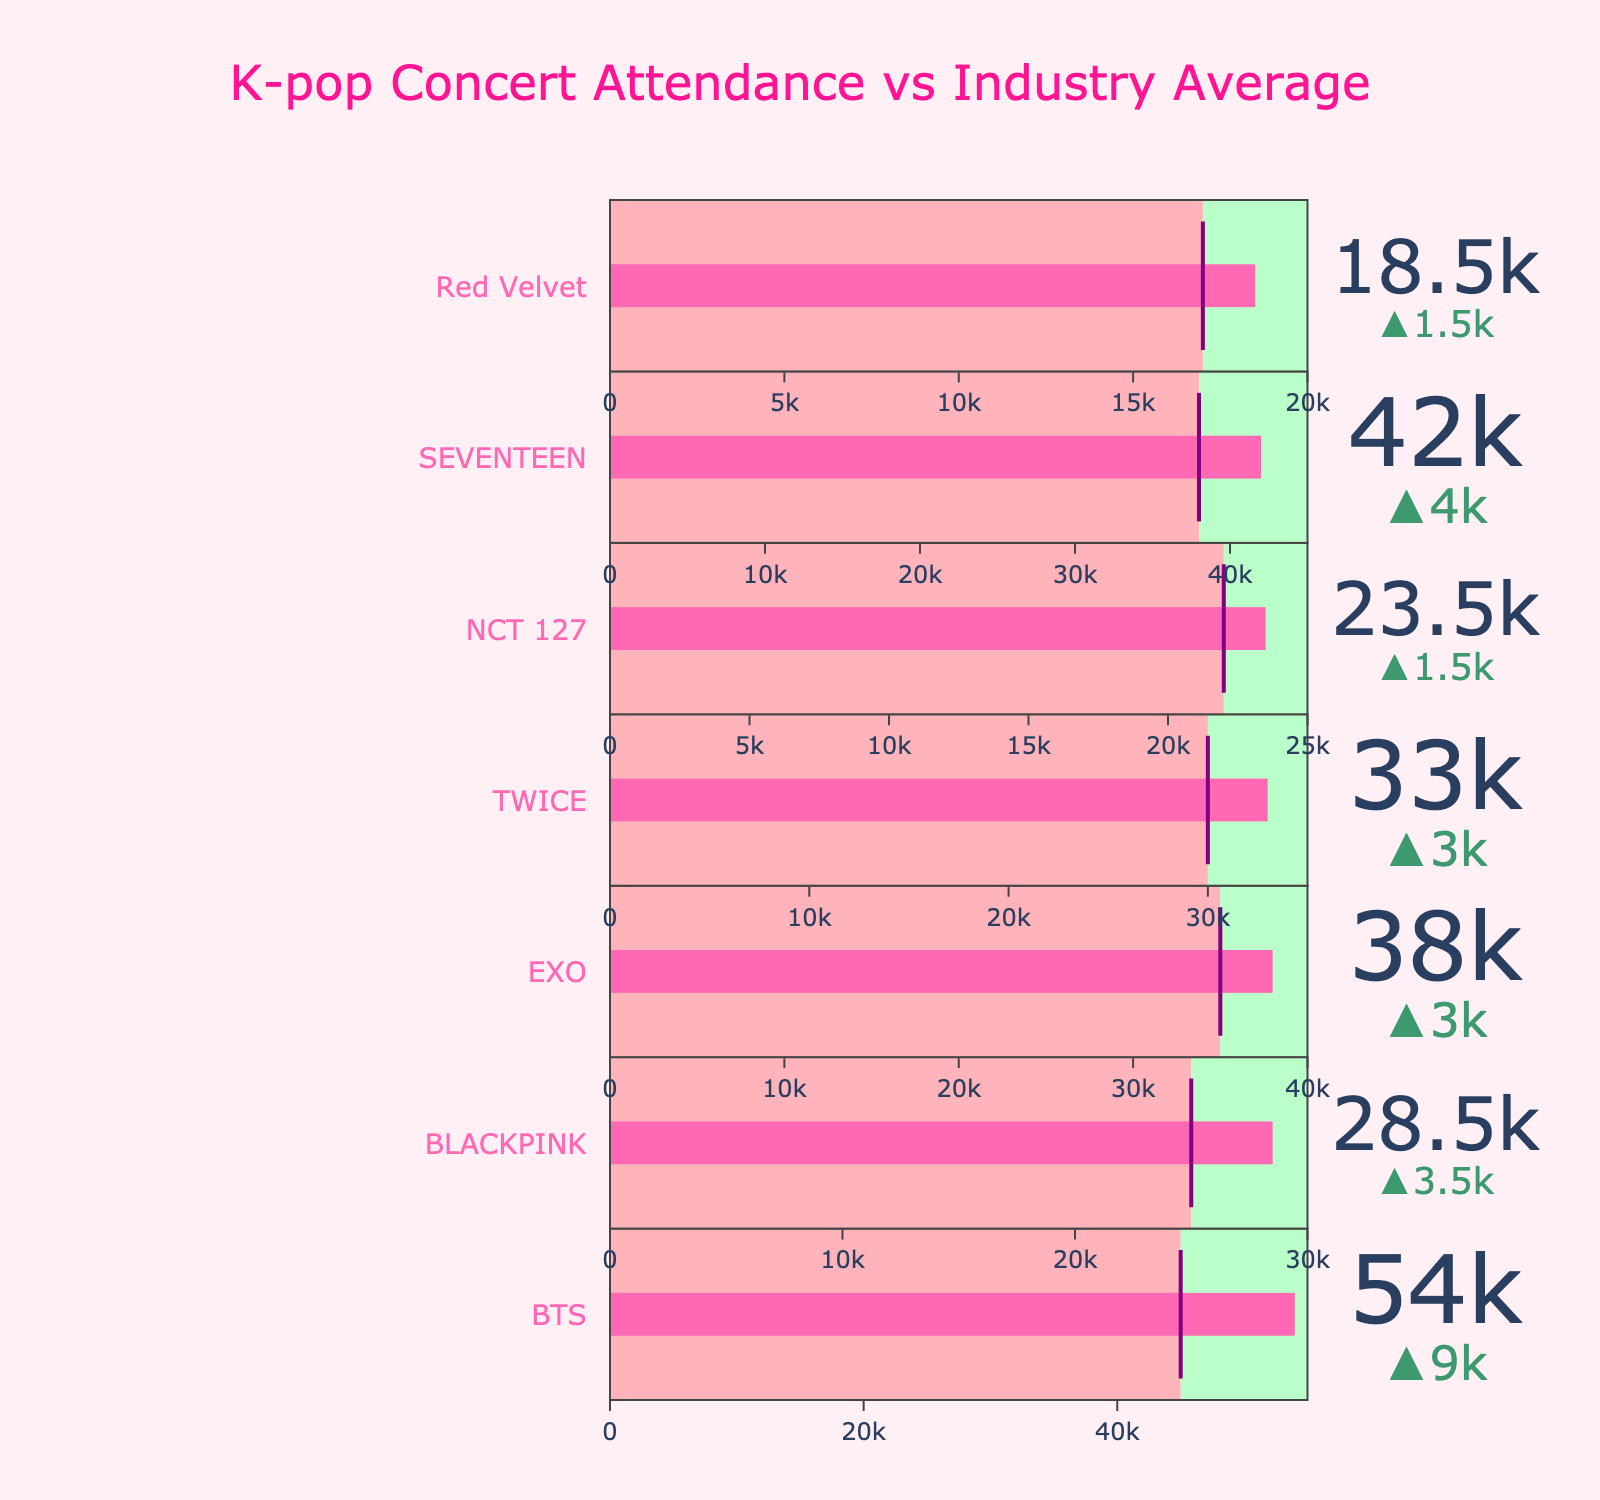Which artist performed in the largest venue? The sizes of the venues can be compared by looking at the "Venue Capacity" values. BTS has the largest venue capacity of 55,000.
Answer: BTS Which artist sold the most tickets? To determine this, we need to check the "Tickets Sold" values. BTS sold the most tickets with 54,000.
Answer: BTS By how much did SEVENTEEN exceed the industry average in ticket sales? SEVENTEEN's "Tickets Sold" subtracts their "Industry Average". 42,000 - 38,000 equals 4,000.
Answer: 4,000 Who had the closest number of tickets sold to their venue's capacity? Comparing "Tickets Sold" and "Venue Capacity" for all acts, BTS had 54,000 tickets sold out of 55,000, which is the smallest difference of 1,000.
Answer: BTS Which artist underperformed compared to the industry average? We need to spot if any "Tickets Sold" values are below their "Industry Average". In this case, none of the artists underperformed compared to the industry average.
Answer: None Which artist sold fewer tickets than TWICE? Checking the list, only NCT 127 and Red Velvet sold fewer tickets with 23,500 and 18,500 respectively.
Answer: NCT 127 and Red Velvet What is the total venue capacity for all listed artists? Sum up all "Venue Capacity" values. Total is 55,000 + 30,000 + 40,000 + 35,000 + 25,000 + 45,000 + 20,000, which equals 250,000.
Answer: 250,000 Which artist had the highest surplus of tickets sold over the industry average? Calculate the difference for each artist and compare. BTS's surplus is the highest: 54,000 - 45,000 equals 9,000.
Answer: BTS What percentage of tickets did EXO sell relative to their venue capacity? Divide EXO's "Tickets Sold" by their "Venue Capacity" and multiply by 100. (38,000/40,000) * 100 equals 95%.
Answer: 95% How much more were the tickets sold by BLACKPINK than the industry average? Subtract the "Industry Average" from "Tickets Sold" for BLACKPINK. 28,500 - 25,000 equals 3,500.
Answer: 3,500 